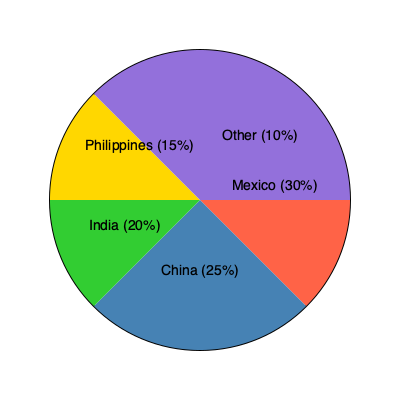Based on the pie chart showing the distribution of immigrant populations by country of origin, which two countries combined account for more than half of the total immigrant population? To answer this question, we need to follow these steps:

1. Identify the percentages for each country:
   - Mexico: 30%
   - China: 25%
   - India: 20%
   - Philippines: 15%
   - Other: 10%

2. Find the two largest percentages:
   - The largest is Mexico with 30%
   - The second largest is China with 25%

3. Add these two percentages:
   $30\% + 25\% = 55\%$

4. Check if the sum is greater than 50%:
   55% is indeed greater than 50%

Therefore, Mexico and China combined account for 55% of the total immigrant population, which is more than half.
Answer: Mexico and China 